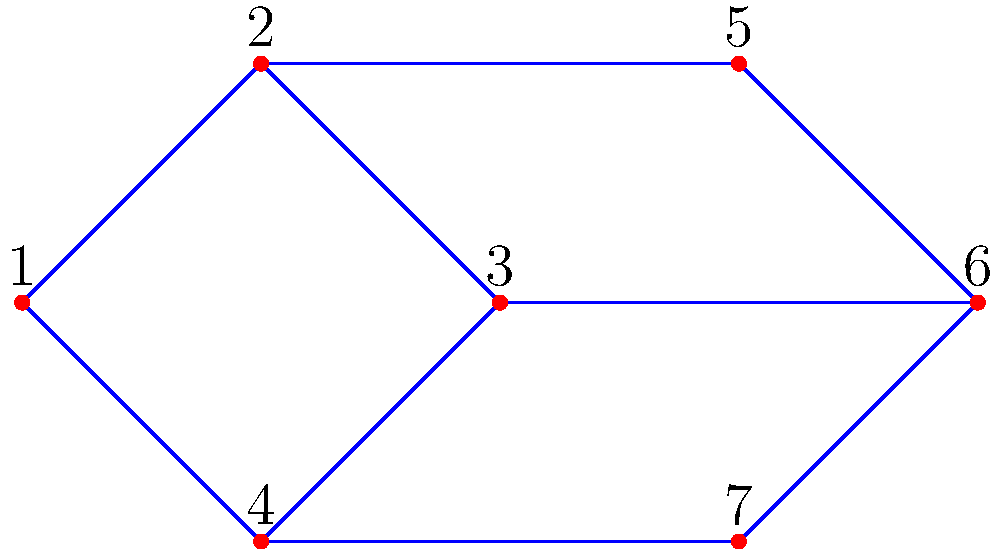Given the network topology of a data center represented by the graph above, where each node represents a server rack and each edge represents a direct network connection, what is the minimum number of edges that need to be removed to disconnect server rack 1 from server rack 6 completely? How does this relate to the concept of edge connectivity in graph theory? To solve this problem, we need to follow these steps:

1. Understand the concept of edge connectivity:
   Edge connectivity is the minimum number of edges that need to be removed to disconnect a graph.

2. Identify all possible paths from server rack 1 to server rack 6:
   Path 1: 1 -> 2 -> 3 -> 6
   Path 2: 1 -> 2 -> 5 -> 6
   Path 3: 1 -> 4 -> 7 -> 6

3. Determine the minimum number of edges to remove:
   To disconnect server rack 1 from server rack 6, we need to remove at least one edge from each path.
   The minimum number of edges to remove is 3, as there are 3 distinct paths.

4. Relation to edge connectivity:
   In this case, the edge connectivity between nodes 1 and 6 is 3. This means that the graph remains connected between these two nodes even if we remove any 2 edges, but becomes disconnected if we remove 3 carefully chosen edges.

5. Importance in data center design:
   Higher edge connectivity implies better fault tolerance and network reliability. In this topology, the data center can maintain connectivity between racks 1 and 6 even if two network links fail.

The edge connectivity concept is crucial for designing robust data center networks, as it helps in creating redundant paths and improving overall network resilience.
Answer: 3 edges; equal to edge connectivity between nodes 1 and 6 